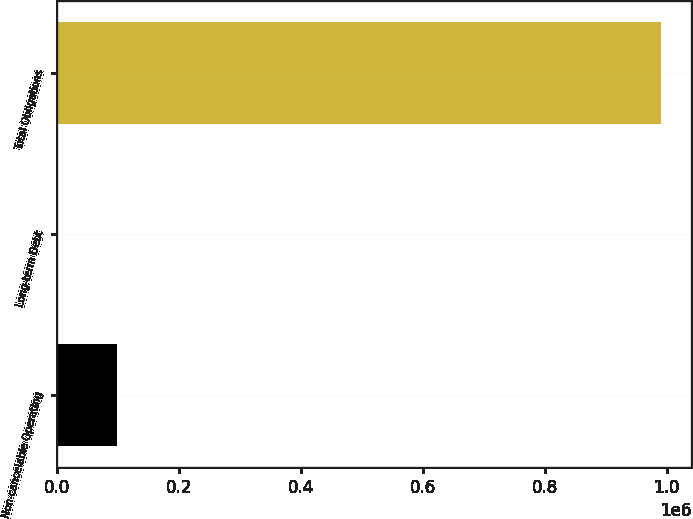Convert chart to OTSL. <chart><loc_0><loc_0><loc_500><loc_500><bar_chart><fcel>Non-cancelable Operating<fcel>Long-term Debt<fcel>Total Obligations<nl><fcel>99117.9<fcel>56<fcel>990675<nl></chart> 